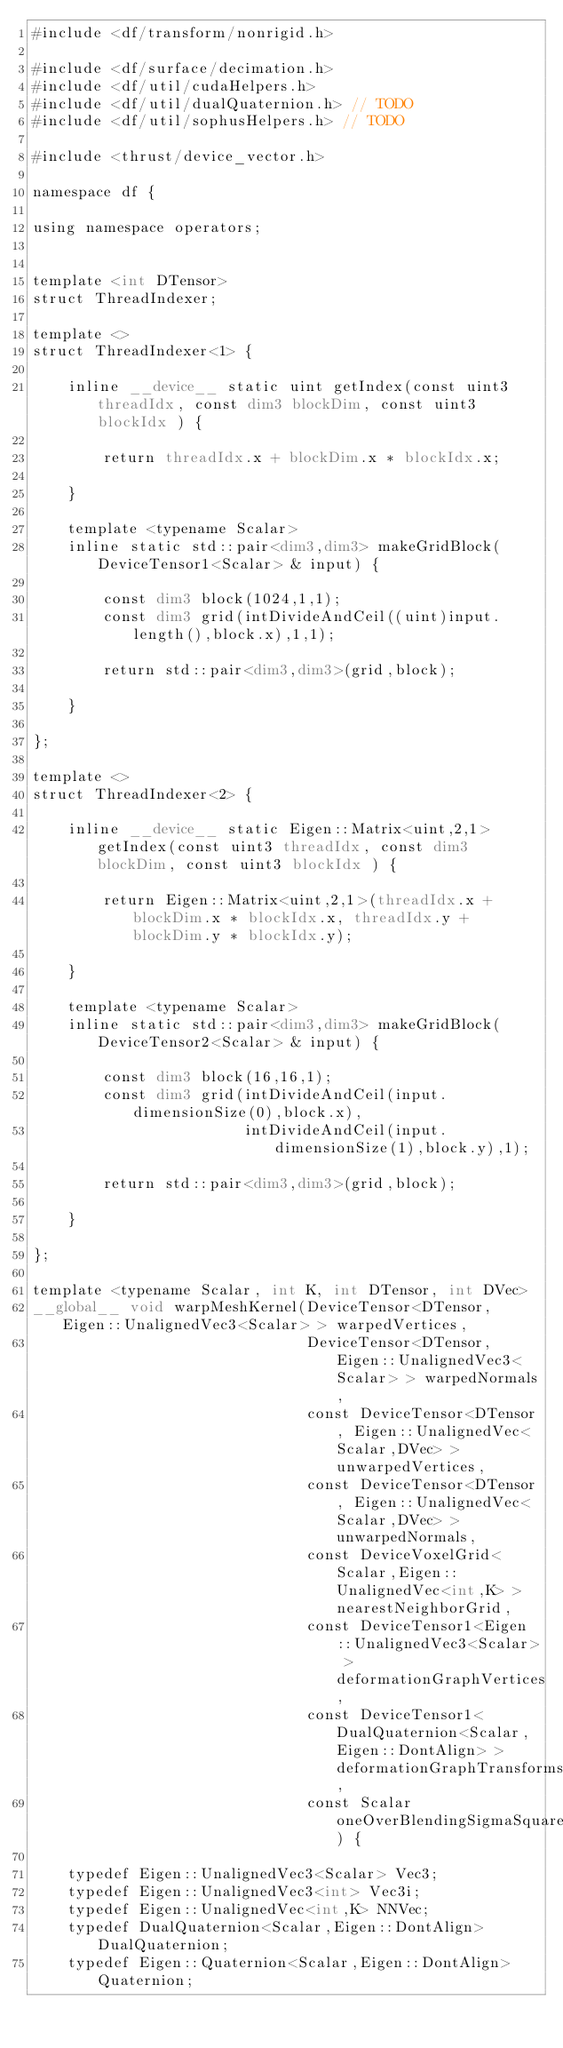<code> <loc_0><loc_0><loc_500><loc_500><_Cuda_>#include <df/transform/nonrigid.h>

#include <df/surface/decimation.h>
#include <df/util/cudaHelpers.h>
#include <df/util/dualQuaternion.h> // TODO
#include <df/util/sophusHelpers.h> // TODO

#include <thrust/device_vector.h>

namespace df {

using namespace operators;


template <int DTensor>
struct ThreadIndexer;

template <>
struct ThreadIndexer<1> {

    inline __device__ static uint getIndex(const uint3 threadIdx, const dim3 blockDim, const uint3 blockIdx ) {

        return threadIdx.x + blockDim.x * blockIdx.x;

    }

    template <typename Scalar>
    inline static std::pair<dim3,dim3> makeGridBlock(DeviceTensor1<Scalar> & input) {

        const dim3 block(1024,1,1);
        const dim3 grid(intDivideAndCeil((uint)input.length(),block.x),1,1);

        return std::pair<dim3,dim3>(grid,block);

    }

};

template <>
struct ThreadIndexer<2> {

    inline __device__ static Eigen::Matrix<uint,2,1> getIndex(const uint3 threadIdx, const dim3 blockDim, const uint3 blockIdx ) {

        return Eigen::Matrix<uint,2,1>(threadIdx.x + blockDim.x * blockIdx.x, threadIdx.y + blockDim.y * blockIdx.y);

    }

    template <typename Scalar>
    inline static std::pair<dim3,dim3> makeGridBlock(DeviceTensor2<Scalar> & input) {

        const dim3 block(16,16,1);
        const dim3 grid(intDivideAndCeil(input.dimensionSize(0),block.x),
                        intDivideAndCeil(input.dimensionSize(1),block.y),1);

        return std::pair<dim3,dim3>(grid,block);

    }

};

template <typename Scalar, int K, int DTensor, int DVec>
__global__ void warpMeshKernel(DeviceTensor<DTensor, Eigen::UnalignedVec3<Scalar> > warpedVertices,
                               DeviceTensor<DTensor, Eigen::UnalignedVec3<Scalar> > warpedNormals,
                               const DeviceTensor<DTensor, Eigen::UnalignedVec<Scalar,DVec> > unwarpedVertices,
                               const DeviceTensor<DTensor, Eigen::UnalignedVec<Scalar,DVec> > unwarpedNormals,
                               const DeviceVoxelGrid<Scalar,Eigen::UnalignedVec<int,K> > nearestNeighborGrid,
                               const DeviceTensor1<Eigen::UnalignedVec3<Scalar> > deformationGraphVertices,
                               const DeviceTensor1<DualQuaternion<Scalar,Eigen::DontAlign> > deformationGraphTransforms,
                               const Scalar oneOverBlendingSigmaSquared) {

    typedef Eigen::UnalignedVec3<Scalar> Vec3;
    typedef Eigen::UnalignedVec3<int> Vec3i;
    typedef Eigen::UnalignedVec<int,K> NNVec;
    typedef DualQuaternion<Scalar,Eigen::DontAlign> DualQuaternion;
    typedef Eigen::Quaternion<Scalar,Eigen::DontAlign> Quaternion;
</code> 